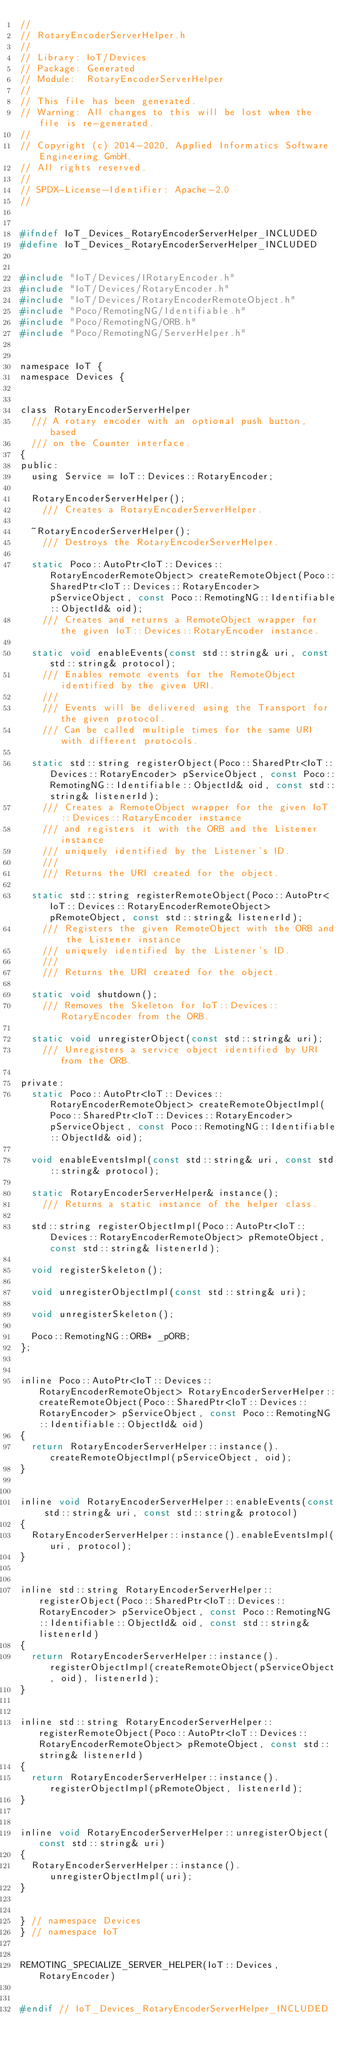<code> <loc_0><loc_0><loc_500><loc_500><_C_>//
// RotaryEncoderServerHelper.h
//
// Library: IoT/Devices
// Package: Generated
// Module:  RotaryEncoderServerHelper
//
// This file has been generated.
// Warning: All changes to this will be lost when the file is re-generated.
//
// Copyright (c) 2014-2020, Applied Informatics Software Engineering GmbH.
// All rights reserved.
// 
// SPDX-License-Identifier: Apache-2.0
//


#ifndef IoT_Devices_RotaryEncoderServerHelper_INCLUDED
#define IoT_Devices_RotaryEncoderServerHelper_INCLUDED


#include "IoT/Devices/IRotaryEncoder.h"
#include "IoT/Devices/RotaryEncoder.h"
#include "IoT/Devices/RotaryEncoderRemoteObject.h"
#include "Poco/RemotingNG/Identifiable.h"
#include "Poco/RemotingNG/ORB.h"
#include "Poco/RemotingNG/ServerHelper.h"


namespace IoT {
namespace Devices {


class RotaryEncoderServerHelper
	/// A rotary encoder with an optional push button, based
	/// on the Counter interface.
{
public:
	using Service = IoT::Devices::RotaryEncoder;

	RotaryEncoderServerHelper();
		/// Creates a RotaryEncoderServerHelper.

	~RotaryEncoderServerHelper();
		/// Destroys the RotaryEncoderServerHelper.

	static Poco::AutoPtr<IoT::Devices::RotaryEncoderRemoteObject> createRemoteObject(Poco::SharedPtr<IoT::Devices::RotaryEncoder> pServiceObject, const Poco::RemotingNG::Identifiable::ObjectId& oid);
		/// Creates and returns a RemoteObject wrapper for the given IoT::Devices::RotaryEncoder instance.

	static void enableEvents(const std::string& uri, const std::string& protocol);
		/// Enables remote events for the RemoteObject identified by the given URI.
		///
		/// Events will be delivered using the Transport for the given protocol.
		/// Can be called multiple times for the same URI with different protocols.

	static std::string registerObject(Poco::SharedPtr<IoT::Devices::RotaryEncoder> pServiceObject, const Poco::RemotingNG::Identifiable::ObjectId& oid, const std::string& listenerId);
		/// Creates a RemoteObject wrapper for the given IoT::Devices::RotaryEncoder instance
		/// and registers it with the ORB and the Listener instance
		/// uniquely identified by the Listener's ID.
		/// 
		///	Returns the URI created for the object.

	static std::string registerRemoteObject(Poco::AutoPtr<IoT::Devices::RotaryEncoderRemoteObject> pRemoteObject, const std::string& listenerId);
		/// Registers the given RemoteObject with the ORB and the Listener instance
		/// uniquely identified by the Listener's ID.
		/// 
		///	Returns the URI created for the object.

	static void shutdown();
		/// Removes the Skeleton for IoT::Devices::RotaryEncoder from the ORB.

	static void unregisterObject(const std::string& uri);
		/// Unregisters a service object identified by URI from the ORB.

private:
	static Poco::AutoPtr<IoT::Devices::RotaryEncoderRemoteObject> createRemoteObjectImpl(Poco::SharedPtr<IoT::Devices::RotaryEncoder> pServiceObject, const Poco::RemotingNG::Identifiable::ObjectId& oid);

	void enableEventsImpl(const std::string& uri, const std::string& protocol);

	static RotaryEncoderServerHelper& instance();
		/// Returns a static instance of the helper class.

	std::string registerObjectImpl(Poco::AutoPtr<IoT::Devices::RotaryEncoderRemoteObject> pRemoteObject, const std::string& listenerId);

	void registerSkeleton();

	void unregisterObjectImpl(const std::string& uri);

	void unregisterSkeleton();

	Poco::RemotingNG::ORB* _pORB;
};


inline Poco::AutoPtr<IoT::Devices::RotaryEncoderRemoteObject> RotaryEncoderServerHelper::createRemoteObject(Poco::SharedPtr<IoT::Devices::RotaryEncoder> pServiceObject, const Poco::RemotingNG::Identifiable::ObjectId& oid)
{
	return RotaryEncoderServerHelper::instance().createRemoteObjectImpl(pServiceObject, oid);
}


inline void RotaryEncoderServerHelper::enableEvents(const std::string& uri, const std::string& protocol)
{
	RotaryEncoderServerHelper::instance().enableEventsImpl(uri, protocol);
}


inline std::string RotaryEncoderServerHelper::registerObject(Poco::SharedPtr<IoT::Devices::RotaryEncoder> pServiceObject, const Poco::RemotingNG::Identifiable::ObjectId& oid, const std::string& listenerId)
{
	return RotaryEncoderServerHelper::instance().registerObjectImpl(createRemoteObject(pServiceObject, oid), listenerId);
}


inline std::string RotaryEncoderServerHelper::registerRemoteObject(Poco::AutoPtr<IoT::Devices::RotaryEncoderRemoteObject> pRemoteObject, const std::string& listenerId)
{
	return RotaryEncoderServerHelper::instance().registerObjectImpl(pRemoteObject, listenerId);
}


inline void RotaryEncoderServerHelper::unregisterObject(const std::string& uri)
{
	RotaryEncoderServerHelper::instance().unregisterObjectImpl(uri);
}


} // namespace Devices
} // namespace IoT


REMOTING_SPECIALIZE_SERVER_HELPER(IoT::Devices, RotaryEncoder)


#endif // IoT_Devices_RotaryEncoderServerHelper_INCLUDED

</code> 